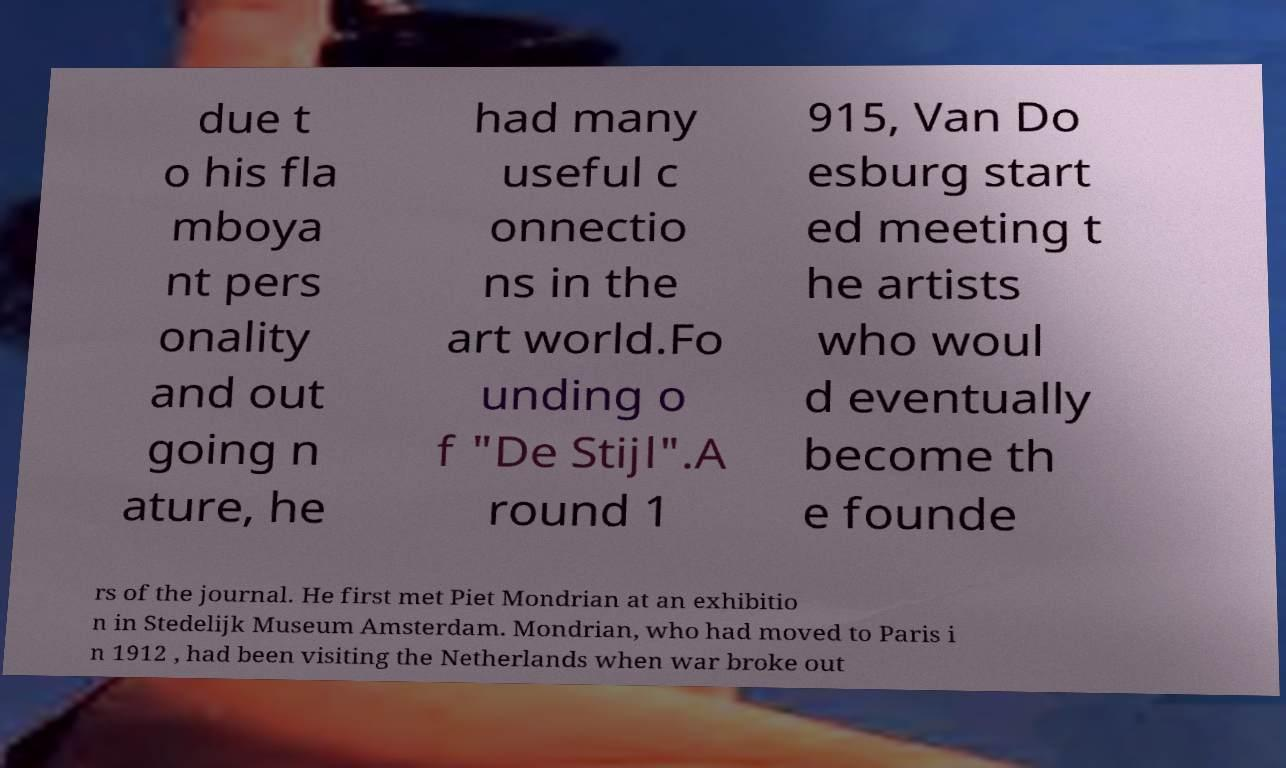Can you read and provide the text displayed in the image?This photo seems to have some interesting text. Can you extract and type it out for me? due t o his fla mboya nt pers onality and out going n ature, he had many useful c onnectio ns in the art world.Fo unding o f "De Stijl".A round 1 915, Van Do esburg start ed meeting t he artists who woul d eventually become th e founde rs of the journal. He first met Piet Mondrian at an exhibitio n in Stedelijk Museum Amsterdam. Mondrian, who had moved to Paris i n 1912 , had been visiting the Netherlands when war broke out 